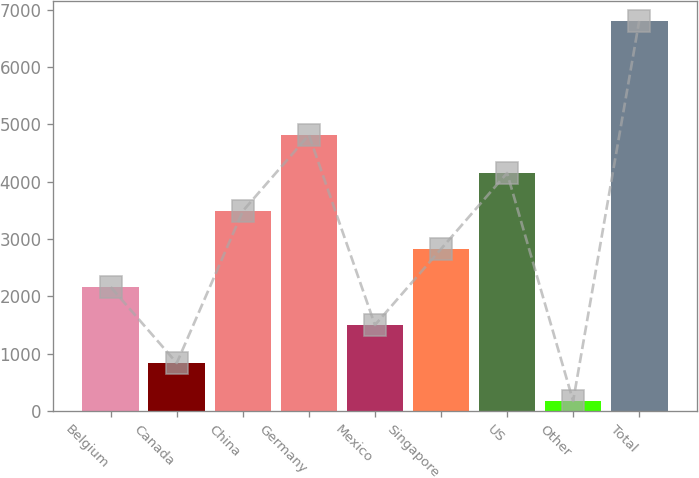<chart> <loc_0><loc_0><loc_500><loc_500><bar_chart><fcel>Belgium<fcel>Canada<fcel>China<fcel>Germany<fcel>Mexico<fcel>Singapore<fcel>US<fcel>Other<fcel>Total<nl><fcel>2163.8<fcel>838.6<fcel>3489<fcel>4814.2<fcel>1501.2<fcel>2826.4<fcel>4151.6<fcel>176<fcel>6802<nl></chart> 